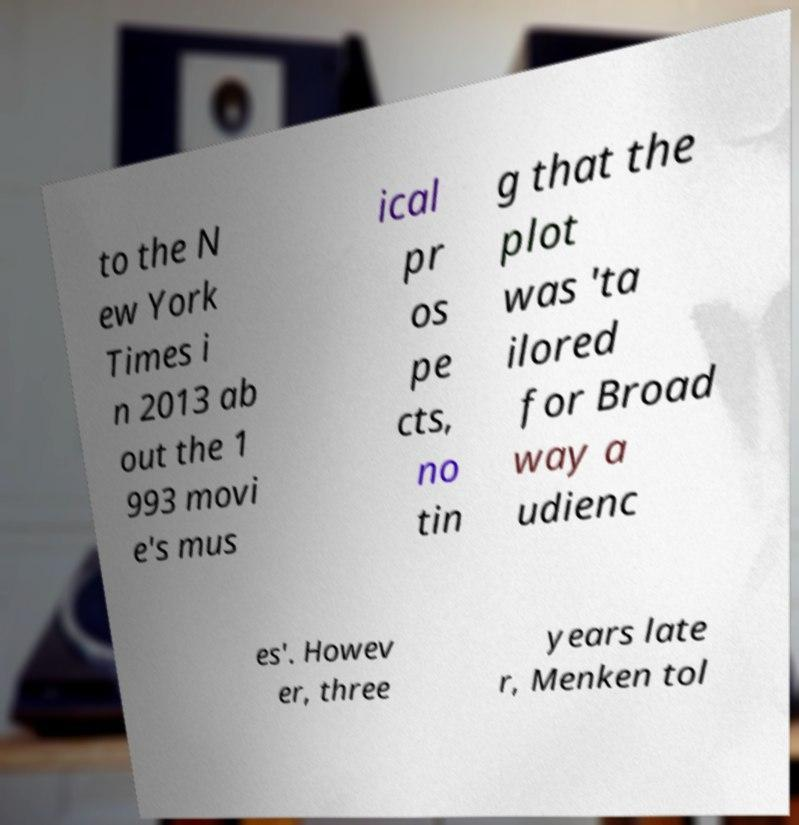Please identify and transcribe the text found in this image. to the N ew York Times i n 2013 ab out the 1 993 movi e's mus ical pr os pe cts, no tin g that the plot was 'ta ilored for Broad way a udienc es'. Howev er, three years late r, Menken tol 